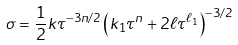<formula> <loc_0><loc_0><loc_500><loc_500>\sigma = \frac { 1 } { 2 } k \tau ^ { - 3 n / 2 } \left ( k _ { 1 } \tau ^ { n } + 2 \ell \tau ^ { \ell _ { 1 } } \right ) ^ { - 3 / 2 }</formula> 